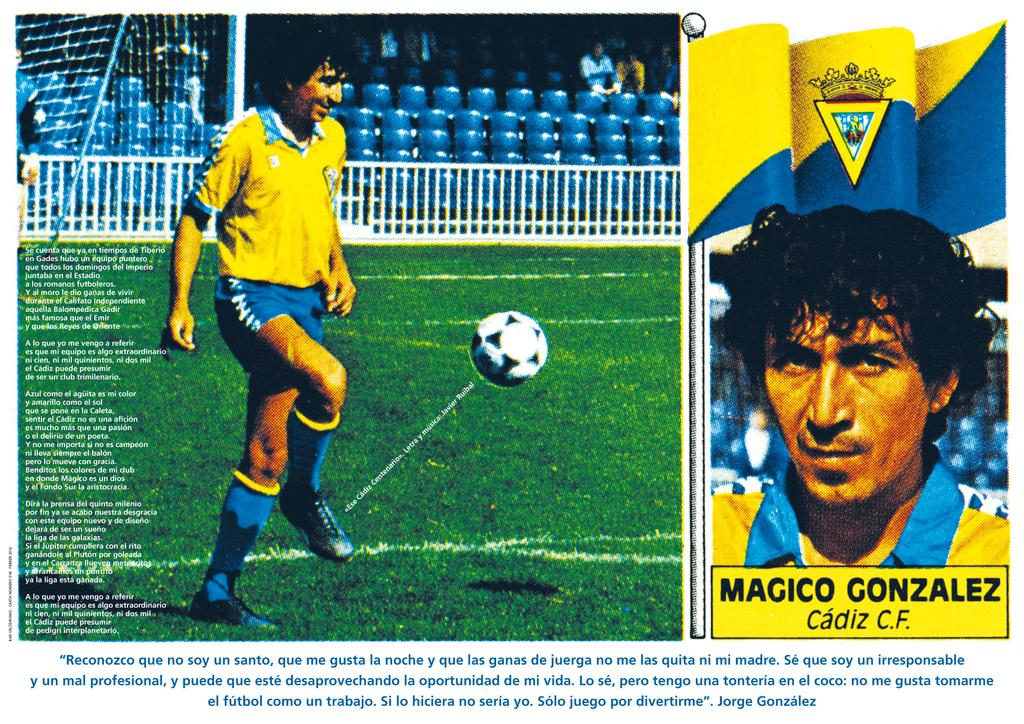What is the main subject of the image? There is a man standing in the image. Where is the man standing? The man is standing on the ground. What other object can be seen in the image? There is a ball in the image. Are there any words or letters in the image? Yes, there is text present in the image. What is the value of the vase in the image? There is no vase present in the image, so it is not possible to determine its value. 